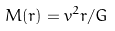<formula> <loc_0><loc_0><loc_500><loc_500>M ( r ) = v ^ { 2 } r / G</formula> 